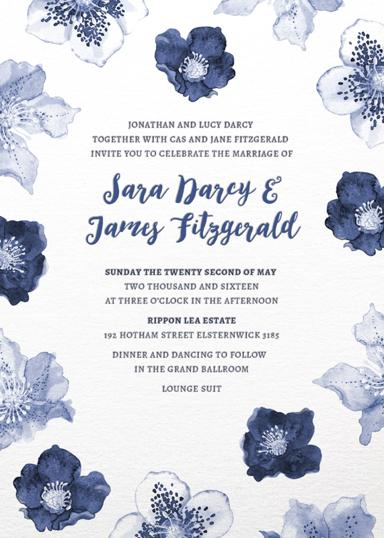Can you describe the significance of the chosen location, Rippon Lea Estate, for the wedding? Rippon Lea Estate, a heritage-listed site, offers a stunning backdrop for weddings with its lush gardens and historic mansion, providing a blend of cultural richness and natural beauty ideal for a memorable and picturesque wedding. 